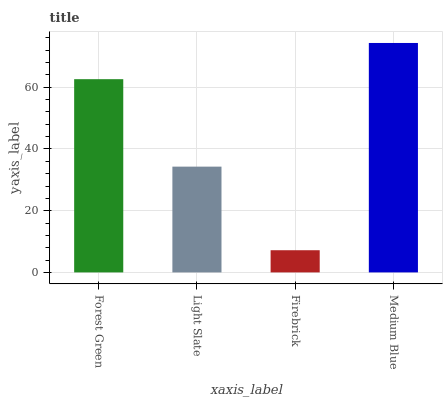Is Firebrick the minimum?
Answer yes or no. Yes. Is Medium Blue the maximum?
Answer yes or no. Yes. Is Light Slate the minimum?
Answer yes or no. No. Is Light Slate the maximum?
Answer yes or no. No. Is Forest Green greater than Light Slate?
Answer yes or no. Yes. Is Light Slate less than Forest Green?
Answer yes or no. Yes. Is Light Slate greater than Forest Green?
Answer yes or no. No. Is Forest Green less than Light Slate?
Answer yes or no. No. Is Forest Green the high median?
Answer yes or no. Yes. Is Light Slate the low median?
Answer yes or no. Yes. Is Medium Blue the high median?
Answer yes or no. No. Is Medium Blue the low median?
Answer yes or no. No. 